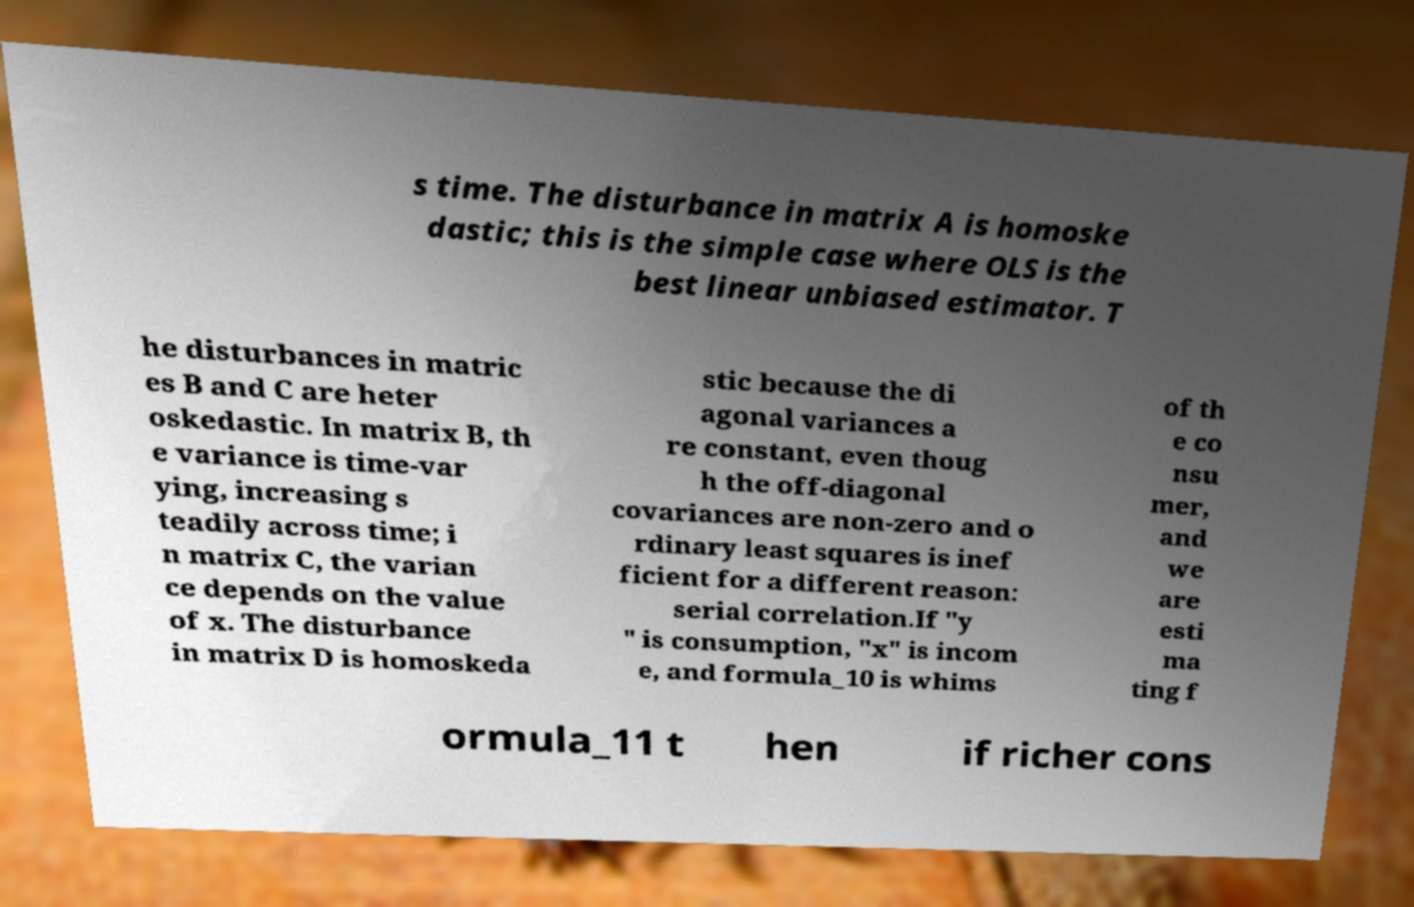There's text embedded in this image that I need extracted. Can you transcribe it verbatim? s time. The disturbance in matrix A is homoske dastic; this is the simple case where OLS is the best linear unbiased estimator. T he disturbances in matric es B and C are heter oskedastic. In matrix B, th e variance is time-var ying, increasing s teadily across time; i n matrix C, the varian ce depends on the value of x. The disturbance in matrix D is homoskeda stic because the di agonal variances a re constant, even thoug h the off-diagonal covariances are non-zero and o rdinary least squares is inef ficient for a different reason: serial correlation.If "y " is consumption, "x" is incom e, and formula_10 is whims of th e co nsu mer, and we are esti ma ting f ormula_11 t hen if richer cons 